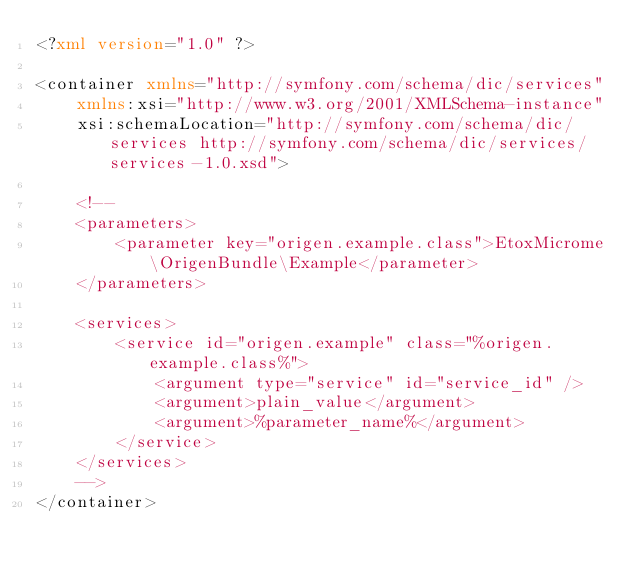<code> <loc_0><loc_0><loc_500><loc_500><_XML_><?xml version="1.0" ?>

<container xmlns="http://symfony.com/schema/dic/services"
    xmlns:xsi="http://www.w3.org/2001/XMLSchema-instance"
    xsi:schemaLocation="http://symfony.com/schema/dic/services http://symfony.com/schema/dic/services/services-1.0.xsd">

    <!--
    <parameters>
        <parameter key="origen.example.class">EtoxMicrome\OrigenBundle\Example</parameter>
    </parameters>

    <services>
        <service id="origen.example" class="%origen.example.class%">
            <argument type="service" id="service_id" />
            <argument>plain_value</argument>
            <argument>%parameter_name%</argument>
        </service>
    </services>
    -->
</container>
</code> 